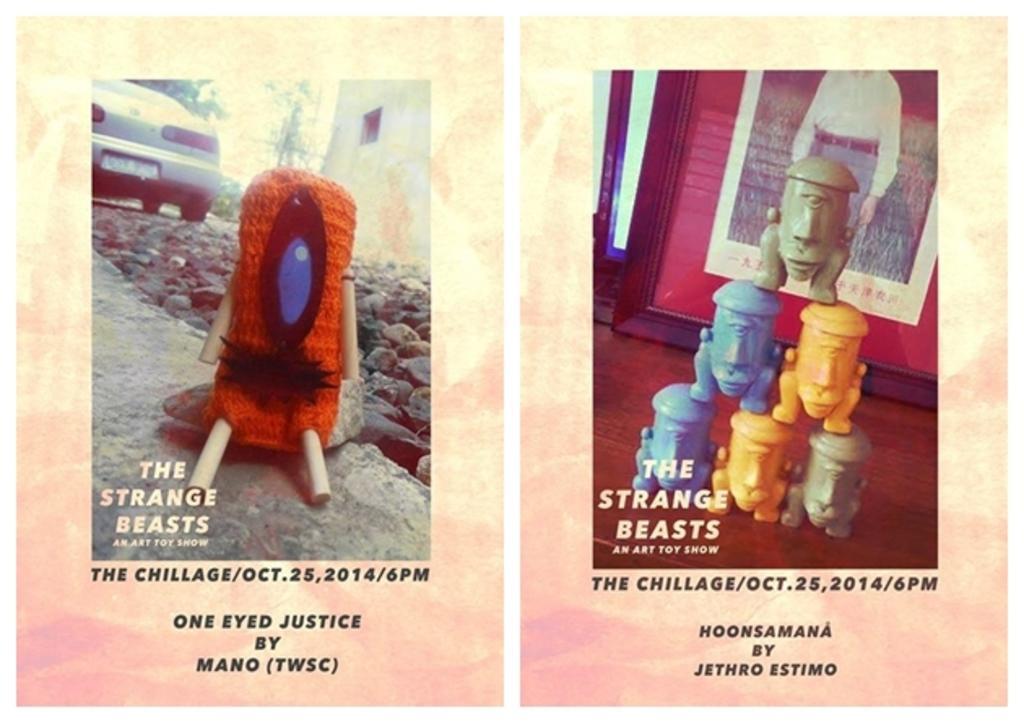Describe this image in one or two sentences. This image consists of a poster with a few images and a text on it. In this image there is a car parked on the ground and there is a toy. There are a few pebbles. On the right side of the image there are a few toys on the floor and there is a poster on the wall. 